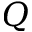<formula> <loc_0><loc_0><loc_500><loc_500>Q</formula> 